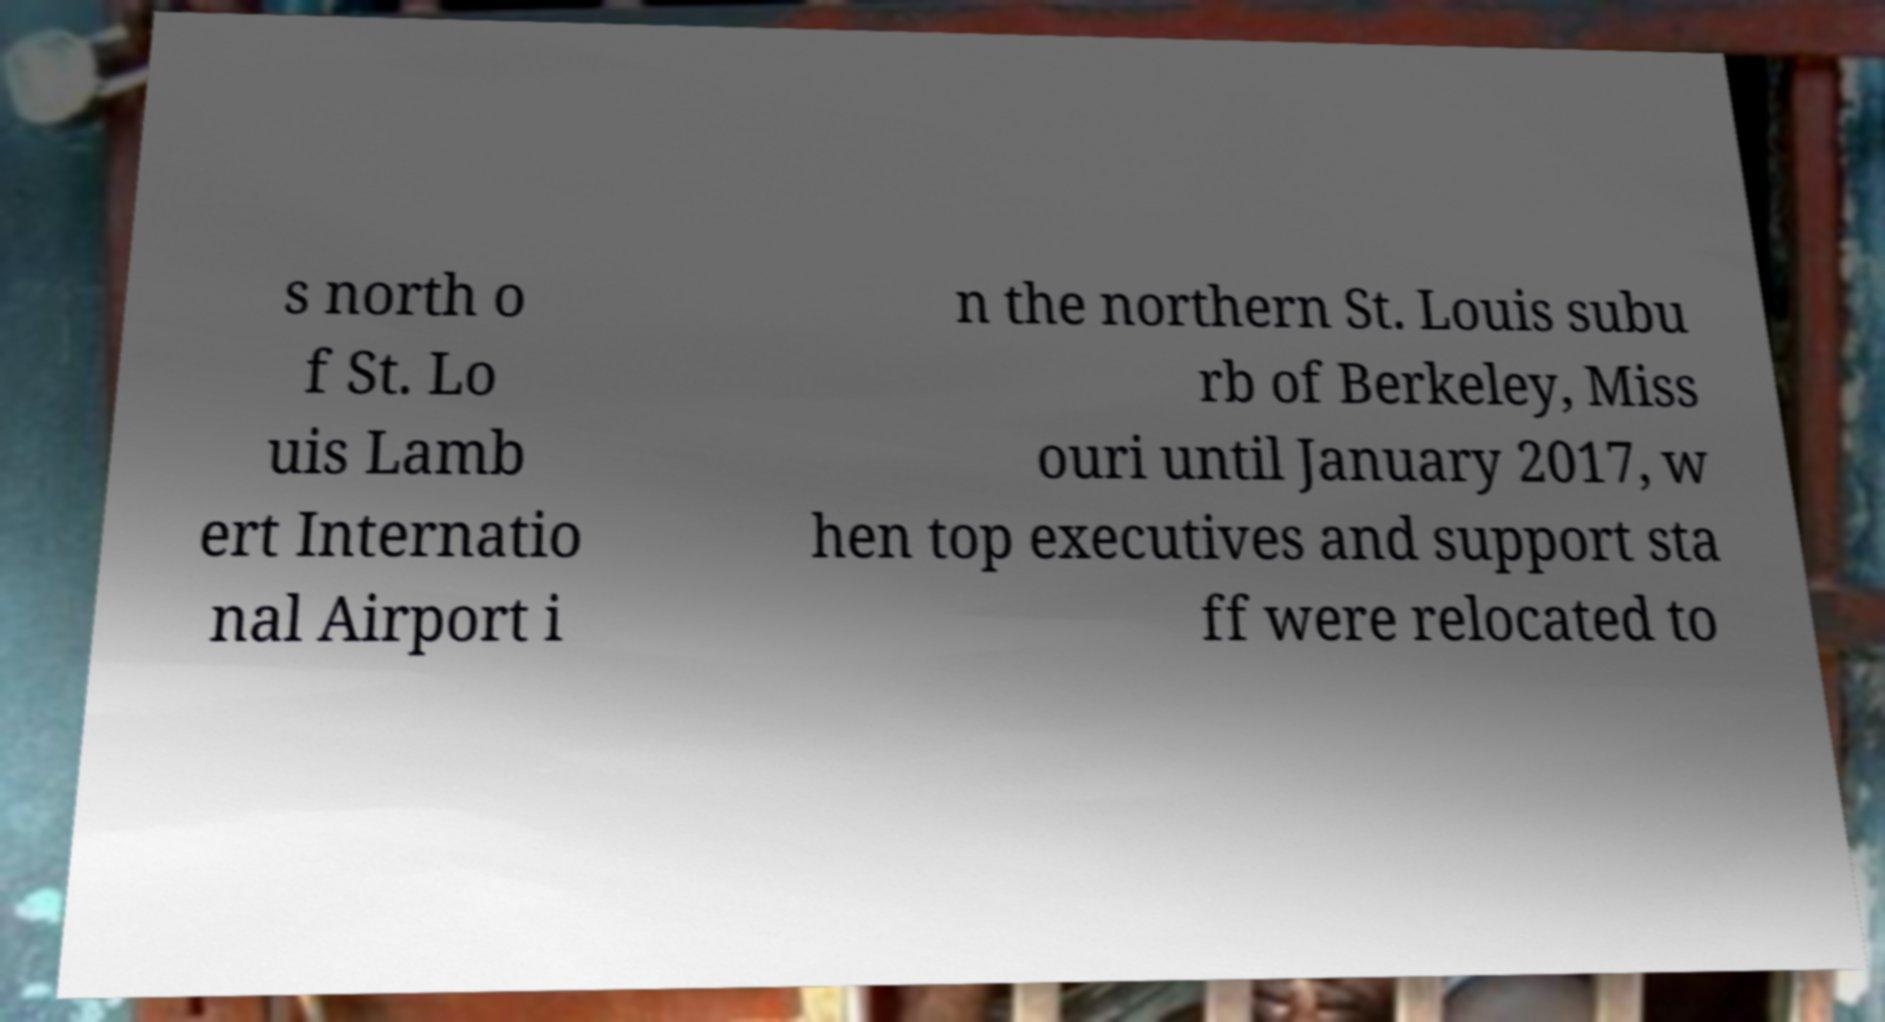I need the written content from this picture converted into text. Can you do that? s north o f St. Lo uis Lamb ert Internatio nal Airport i n the northern St. Louis subu rb of Berkeley, Miss ouri until January 2017, w hen top executives and support sta ff were relocated to 